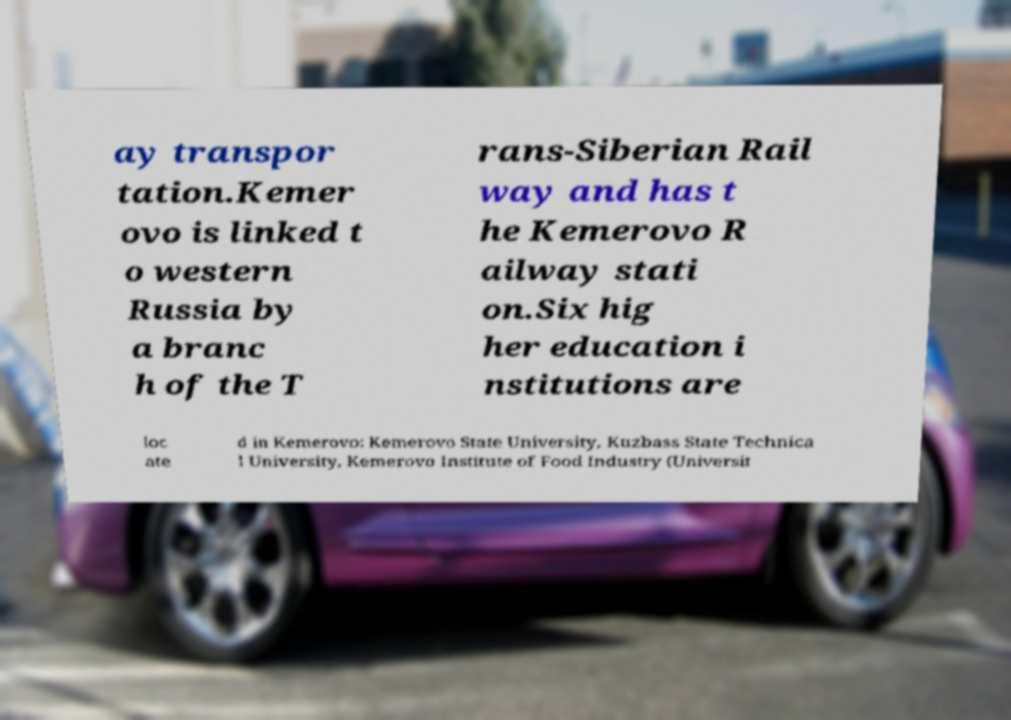Could you assist in decoding the text presented in this image and type it out clearly? ay transpor tation.Kemer ovo is linked t o western Russia by a branc h of the T rans-Siberian Rail way and has t he Kemerovo R ailway stati on.Six hig her education i nstitutions are loc ate d in Kemerovo: Kemerovo State University, Kuzbass State Technica l University, Kemerovo Institute of Food Industry (Universit 